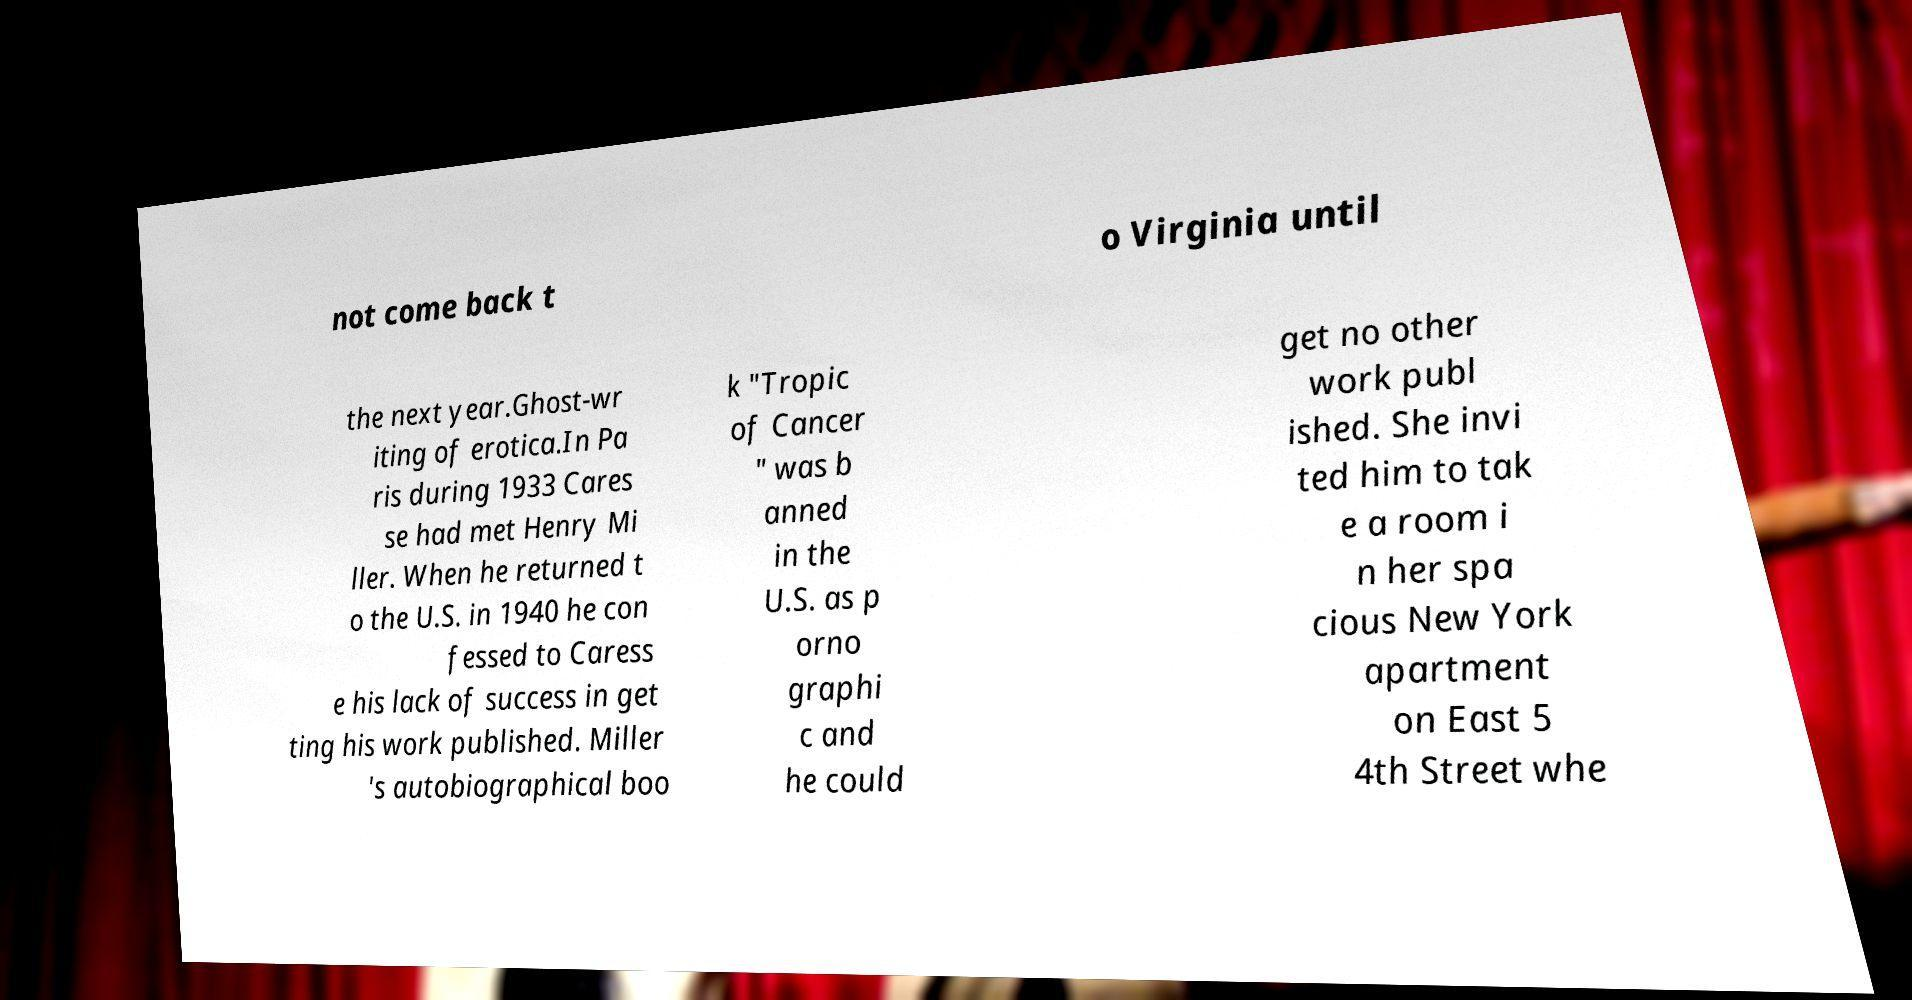Can you accurately transcribe the text from the provided image for me? not come back t o Virginia until the next year.Ghost-wr iting of erotica.In Pa ris during 1933 Cares se had met Henry Mi ller. When he returned t o the U.S. in 1940 he con fessed to Caress e his lack of success in get ting his work published. Miller 's autobiographical boo k "Tropic of Cancer " was b anned in the U.S. as p orno graphi c and he could get no other work publ ished. She invi ted him to tak e a room i n her spa cious New York apartment on East 5 4th Street whe 